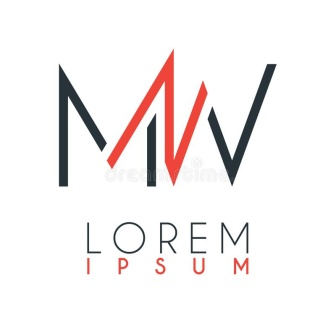What kind of businesses might this logo represent? Given its clean and professional look, this logo could represent a variety of modern businesses, especially those in the tech, design, or consulting sectors. It conveys sophistication and efficiency, which are appealing qualities for companies seeking to project a cutting-edge and trustworthy image. 